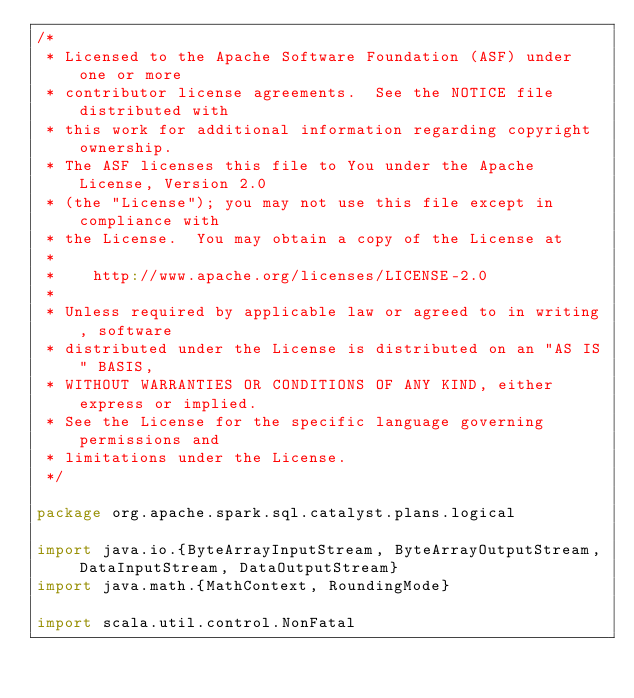Convert code to text. <code><loc_0><loc_0><loc_500><loc_500><_Scala_>/*
 * Licensed to the Apache Software Foundation (ASF) under one or more
 * contributor license agreements.  See the NOTICE file distributed with
 * this work for additional information regarding copyright ownership.
 * The ASF licenses this file to You under the Apache License, Version 2.0
 * (the "License"); you may not use this file except in compliance with
 * the License.  You may obtain a copy of the License at
 *
 *    http://www.apache.org/licenses/LICENSE-2.0
 *
 * Unless required by applicable law or agreed to in writing, software
 * distributed under the License is distributed on an "AS IS" BASIS,
 * WITHOUT WARRANTIES OR CONDITIONS OF ANY KIND, either express or implied.
 * See the License for the specific language governing permissions and
 * limitations under the License.
 */

package org.apache.spark.sql.catalyst.plans.logical

import java.io.{ByteArrayInputStream, ByteArrayOutputStream, DataInputStream, DataOutputStream}
import java.math.{MathContext, RoundingMode}

import scala.util.control.NonFatal
</code> 